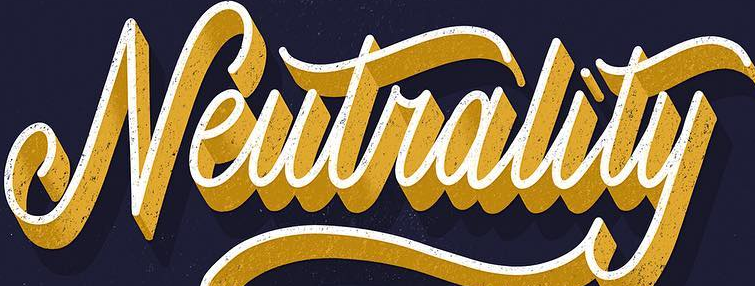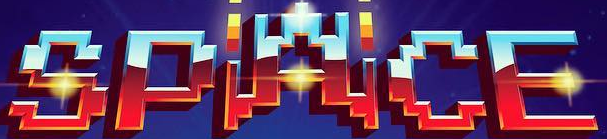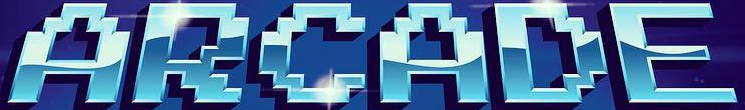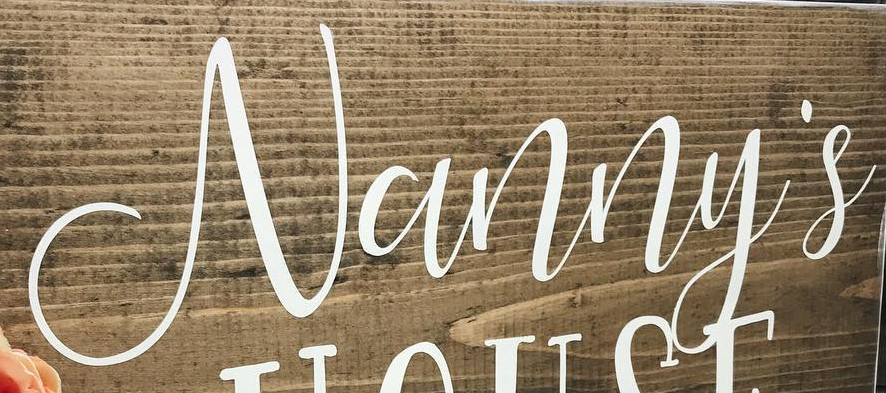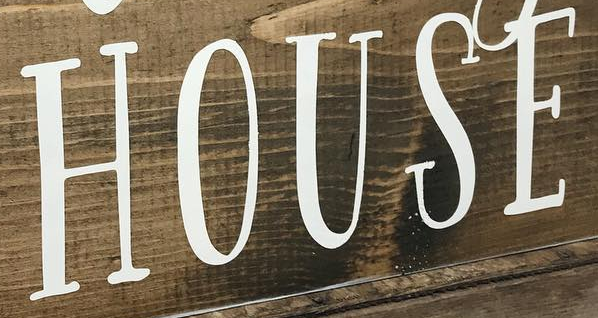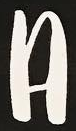Read the text from these images in sequence, separated by a semicolon. Neutrality; SPACE; ARCADE; Vanny's; HOUSE; A 